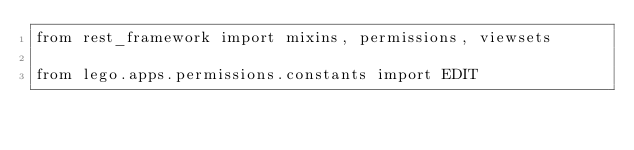<code> <loc_0><loc_0><loc_500><loc_500><_Python_>from rest_framework import mixins, permissions, viewsets

from lego.apps.permissions.constants import EDIT</code> 